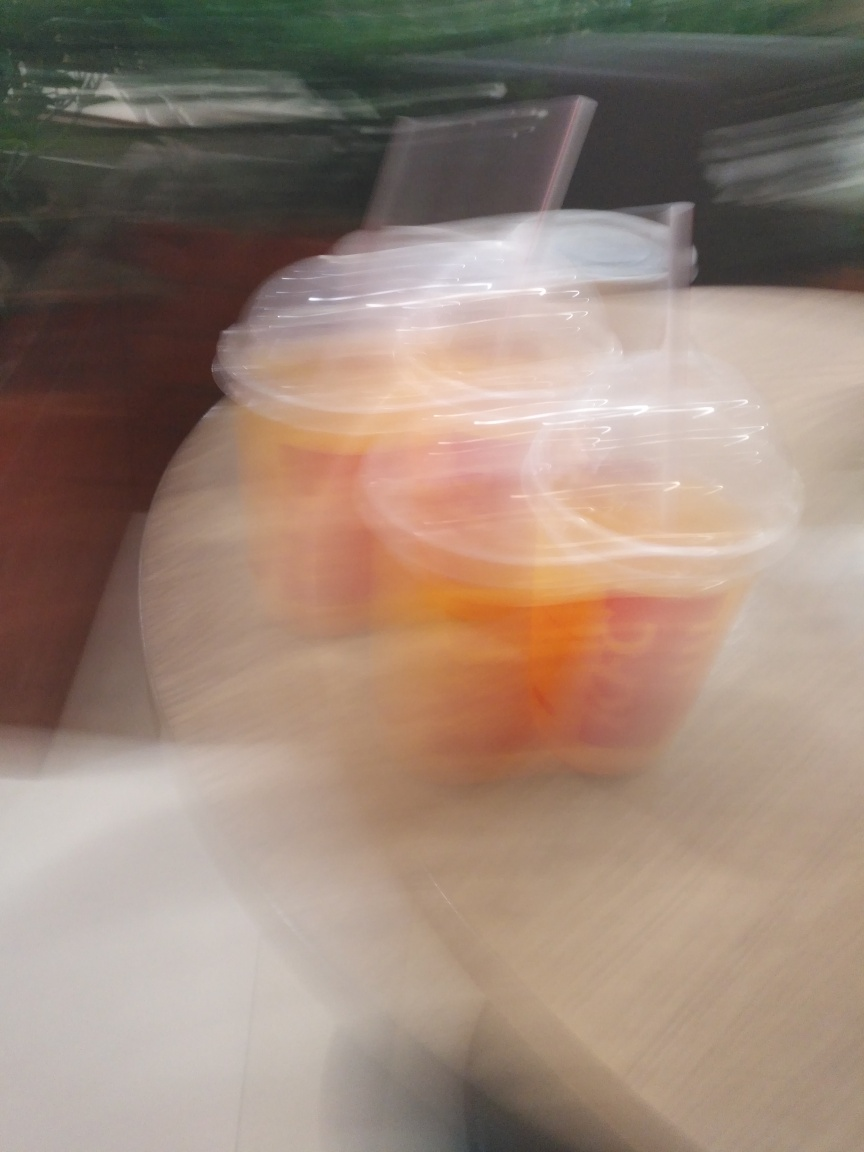Is the lighting sufficient in this image? Based on the image, it appears that there is a motion blur which suggests either a quick movement during the capture or a low shutter speed often used in low light conditions. However, without clearer details, it's challenging to accurately assess the lighting quality. The image does not show clear signs of underexposure that would indicate insufficient lighting, but the motion blur prevents a definitive conclusion. 